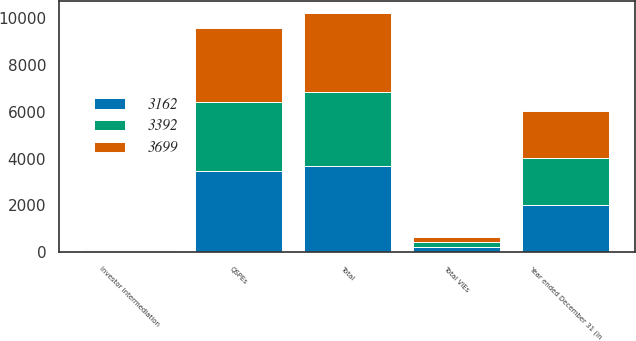<chart> <loc_0><loc_0><loc_500><loc_500><stacked_bar_chart><ecel><fcel>Year ended December 31 (in<fcel>Investor intermediation<fcel>Total VIEs<fcel>QSPEs<fcel>Total<nl><fcel>3162<fcel>2007<fcel>33<fcel>220<fcel>3479<fcel>3699<nl><fcel>3699<fcel>2006<fcel>49<fcel>209<fcel>3183<fcel>3392<nl><fcel>3392<fcel>2005<fcel>50<fcel>222<fcel>2940<fcel>3162<nl></chart> 